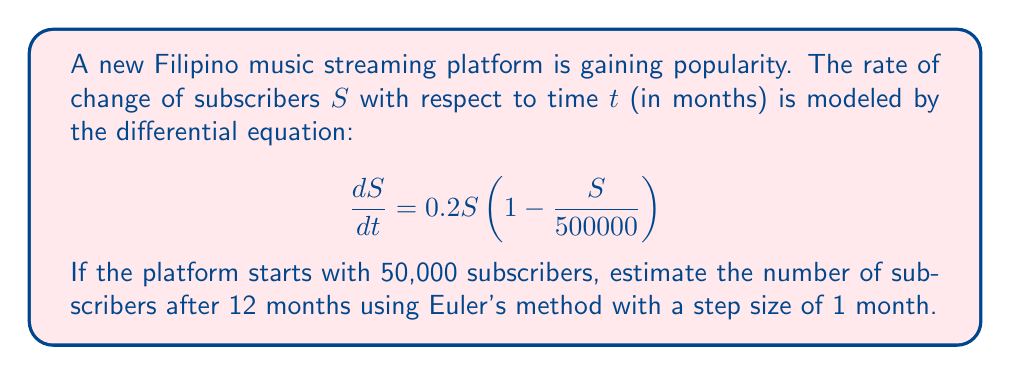Can you answer this question? To solve this problem using Euler's method, we'll follow these steps:

1) Euler's method is given by the formula:
   $S_{n+1} = S_n + h \cdot f(t_n, S_n)$
   where $h$ is the step size, and $f(t, S) = \frac{dS}{dt}$

2) In this case, $f(t, S) = 0.2S(1 - \frac{S}{500000})$, $h = 1$ month, and $S_0 = 50000$

3) We'll calculate 12 steps:

   For $n = 0$:
   $S_1 = 50000 + 1 \cdot 0.2 \cdot 50000(1 - \frac{50000}{500000}) = 59000$

   For $n = 1$:
   $S_2 = 59000 + 1 \cdot 0.2 \cdot 59000(1 - \frac{59000}{500000}) = 68936$

   For $n = 2$:
   $S_3 = 68936 + 1 \cdot 0.2 \cdot 68936(1 - \frac{68936}{500000}) = 79628$

   Continuing this process for the remaining steps...

   $S_4 = 90879$
   $S_5 = 102485$
   $S_6 = 114243$
   $S_7 = 125955$
   $S_8 = 137440$
   $S_9 = 148541$
   $S_{10} = 159125$
   $S_{11} = 169085$
   $S_{12} = 178342$

4) Therefore, after 12 months, the estimated number of subscribers is approximately 178,342.
Answer: Approximately 178,342 subscribers 